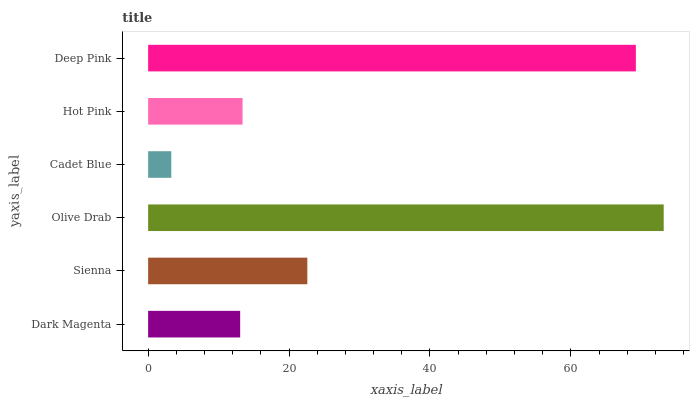Is Cadet Blue the minimum?
Answer yes or no. Yes. Is Olive Drab the maximum?
Answer yes or no. Yes. Is Sienna the minimum?
Answer yes or no. No. Is Sienna the maximum?
Answer yes or no. No. Is Sienna greater than Dark Magenta?
Answer yes or no. Yes. Is Dark Magenta less than Sienna?
Answer yes or no. Yes. Is Dark Magenta greater than Sienna?
Answer yes or no. No. Is Sienna less than Dark Magenta?
Answer yes or no. No. Is Sienna the high median?
Answer yes or no. Yes. Is Hot Pink the low median?
Answer yes or no. Yes. Is Deep Pink the high median?
Answer yes or no. No. Is Sienna the low median?
Answer yes or no. No. 